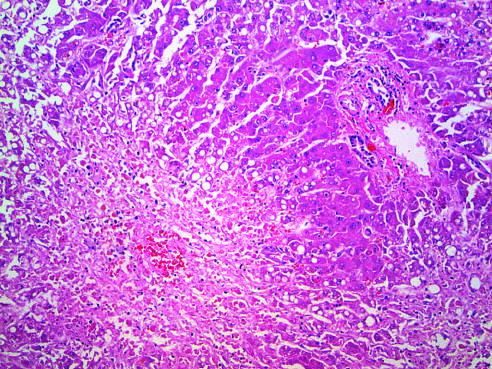s the thrombus seen in the perivenular region zone 3?
Answer the question using a single word or phrase. No 